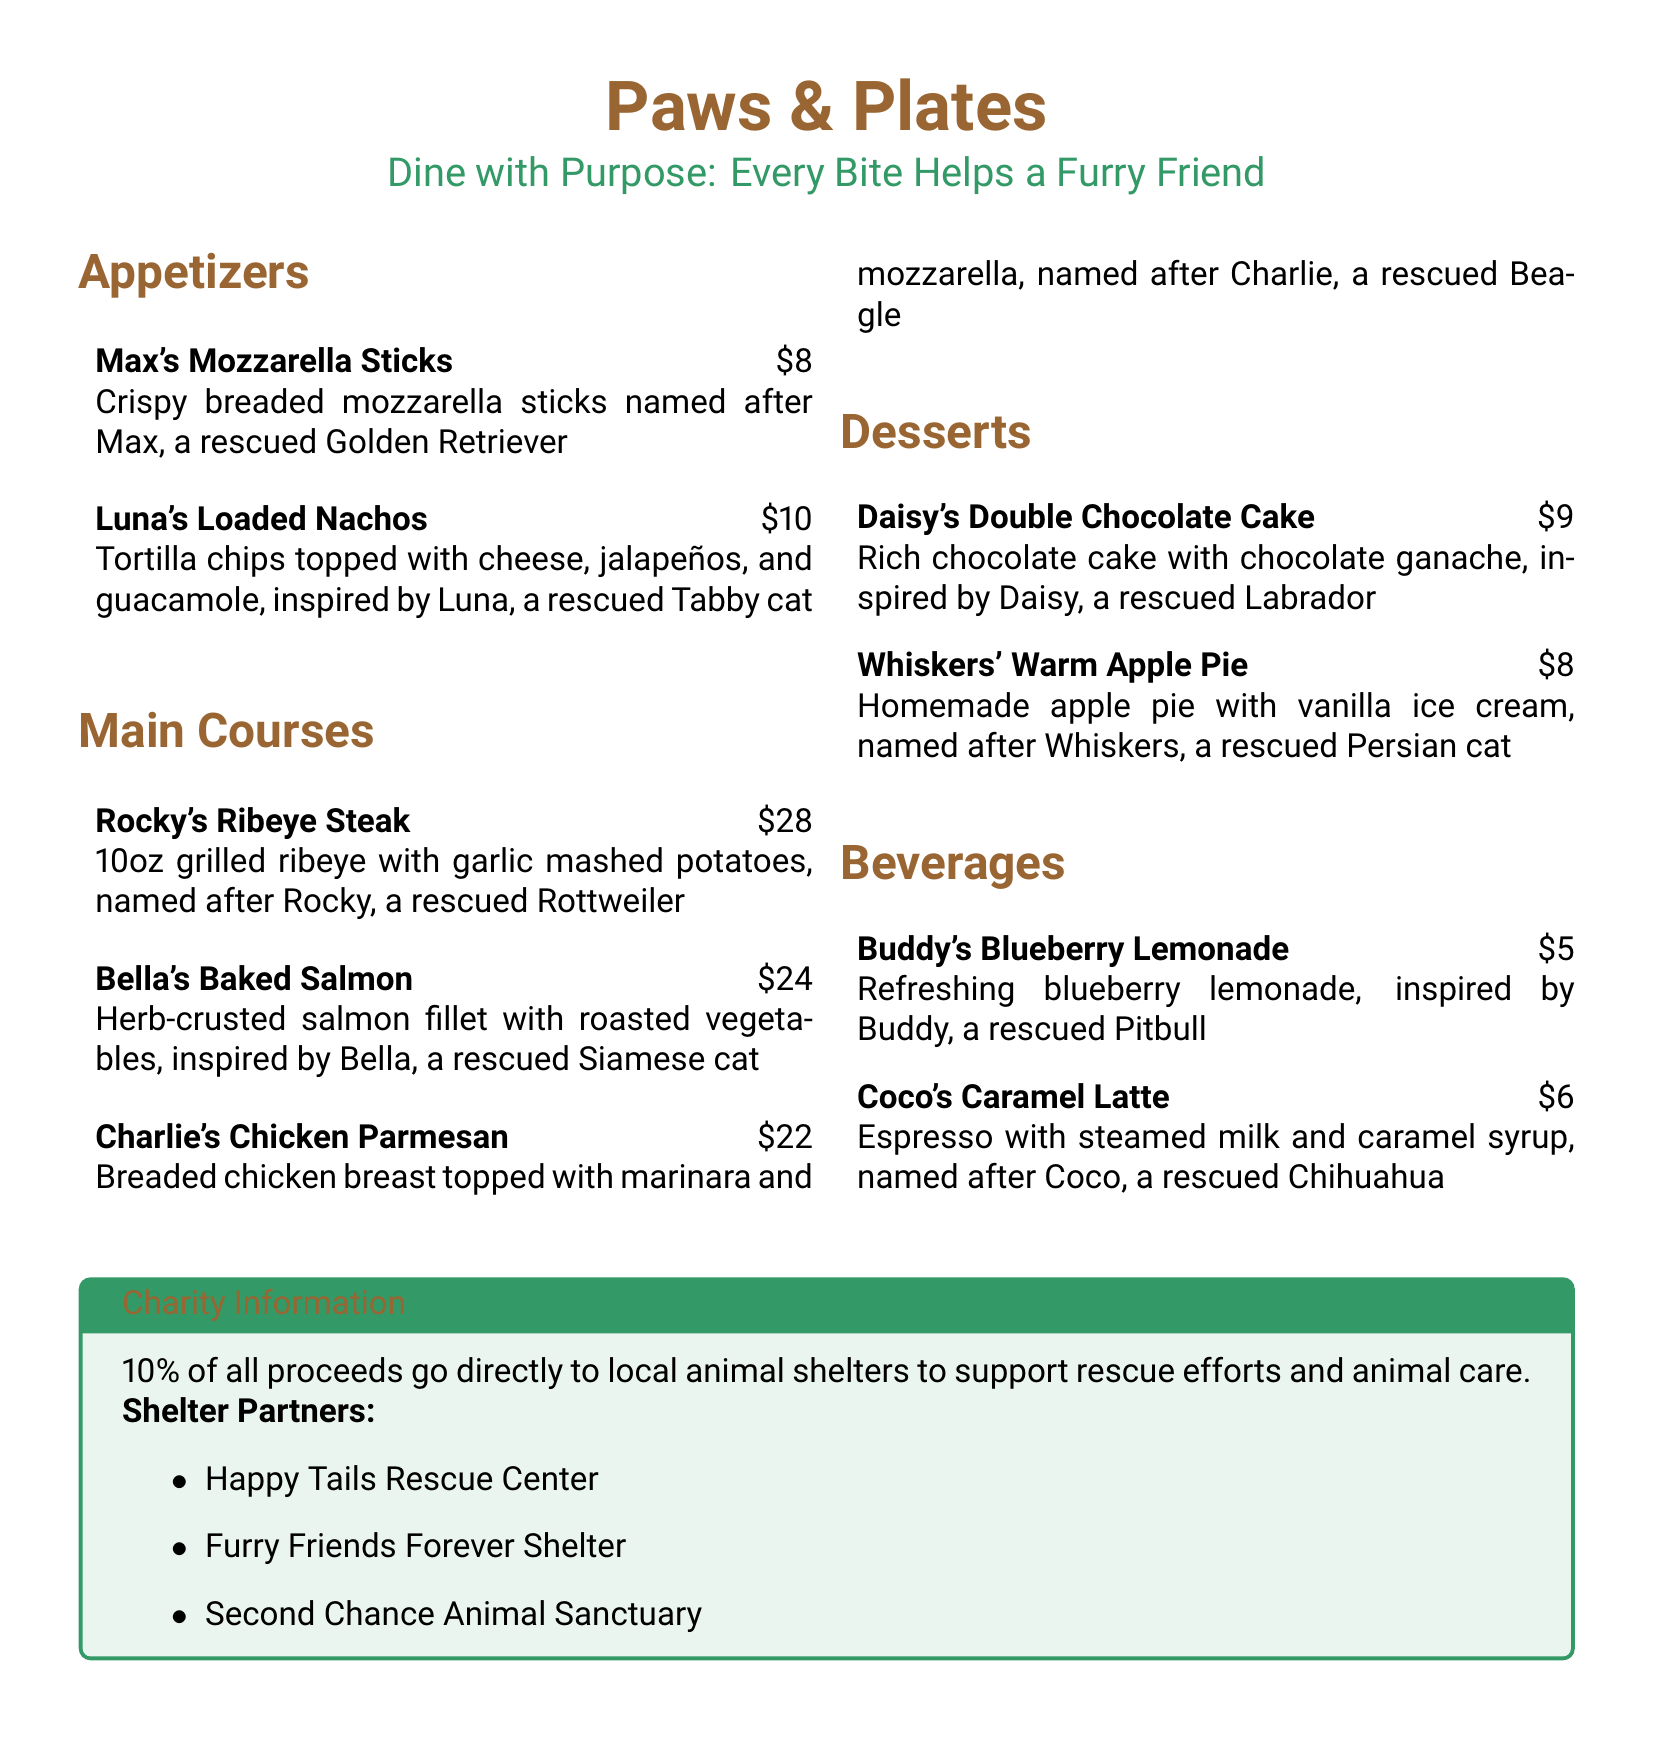What is the name of the appetizer associated with Max? The appetizer named after Max is "Max's Mozzarella Sticks."
Answer: Max's Mozzarella Sticks How much does Rocky's Ribeye Steak cost? The cost of Rocky's Ribeye Steak is listed as $28.
Answer: $28 Which dessert is inspired by a Labrador? The dessert inspired by a Labrador is "Daisy's Double Chocolate Cake."
Answer: Daisy's Double Chocolate Cake What percentage of proceeds go to local animal shelters? The document states that 10% of all proceeds go to local animal shelters.
Answer: 10% Who is Buddy named after? Buddy is named after a rescued Pitbull.
Answer: rescued Pitbull Which beverage includes caramel? The beverage that includes caramel is "Coco's Caramel Latte."
Answer: Coco's Caramel Latte What type of establishment is this document for? This document is for a restaurant menu.
Answer: restaurant menu What animal is Bella's Baked Salmon inspired by? Bella's Baked Salmon is inspired by a rescued Siamese cat.
Answer: rescued Siamese cat 